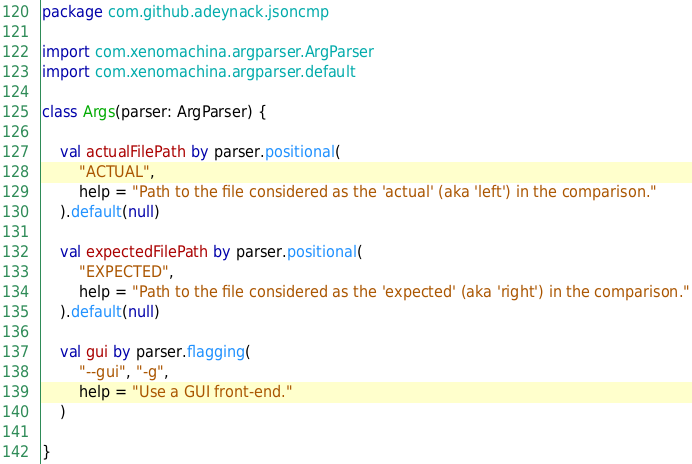Convert code to text. <code><loc_0><loc_0><loc_500><loc_500><_Kotlin_>package com.github.adeynack.jsoncmp

import com.xenomachina.argparser.ArgParser
import com.xenomachina.argparser.default

class Args(parser: ArgParser) {

    val actualFilePath by parser.positional(
        "ACTUAL",
        help = "Path to the file considered as the 'actual' (aka 'left') in the comparison."
    ).default(null)

    val expectedFilePath by parser.positional(
        "EXPECTED",
        help = "Path to the file considered as the 'expected' (aka 'right') in the comparison."
    ).default(null)

    val gui by parser.flagging(
        "--gui", "-g",
        help = "Use a GUI front-end."
    )

}
</code> 